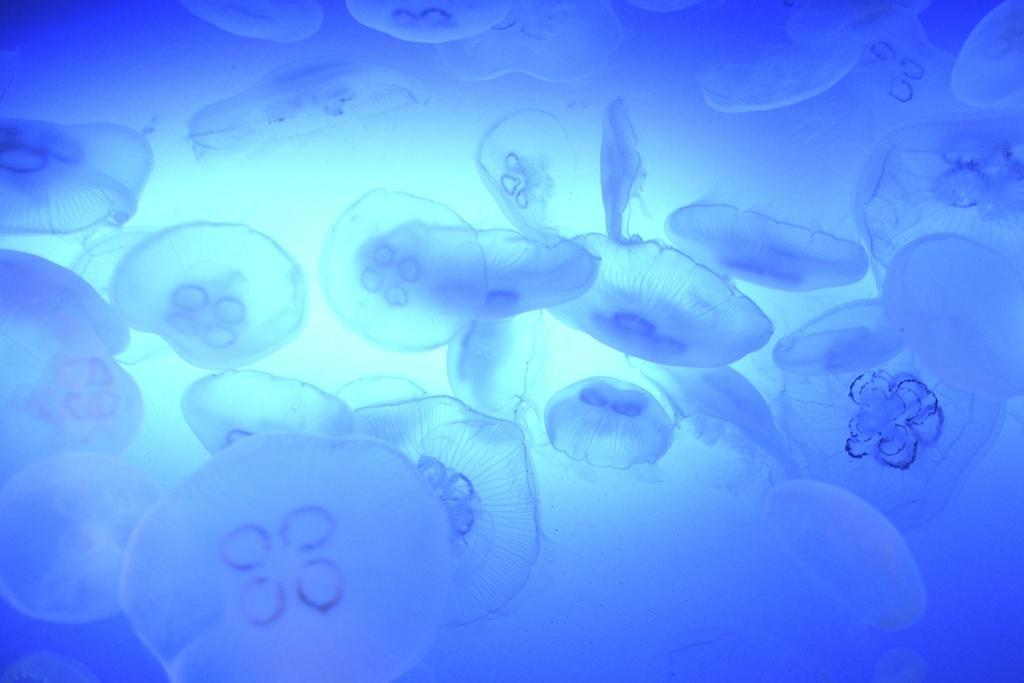Please provide a concise description of this image. In this image we can see aquatic animals. 